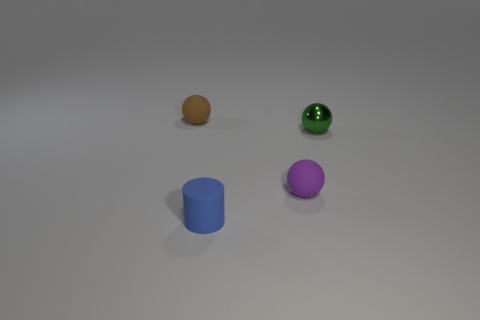Subtract all small matte spheres. How many spheres are left? 1 Subtract all purple balls. How many balls are left? 2 Subtract all cylinders. How many objects are left? 3 Subtract 0 cyan balls. How many objects are left? 4 Subtract 2 balls. How many balls are left? 1 Subtract all gray balls. Subtract all purple cubes. How many balls are left? 3 Subtract all green cylinders. How many red spheres are left? 0 Subtract all big purple rubber cubes. Subtract all tiny cylinders. How many objects are left? 3 Add 1 rubber objects. How many rubber objects are left? 4 Add 1 small purple matte things. How many small purple matte things exist? 2 